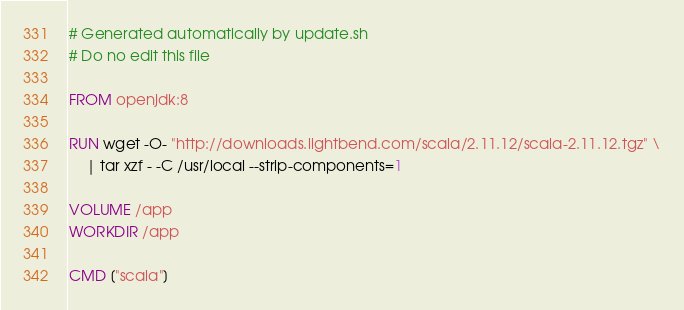Convert code to text. <code><loc_0><loc_0><loc_500><loc_500><_Dockerfile_># Generated automatically by update.sh
# Do no edit this file

FROM openjdk:8

RUN wget -O- "http://downloads.lightbend.com/scala/2.11.12/scala-2.11.12.tgz" \
    | tar xzf - -C /usr/local --strip-components=1

VOLUME /app
WORKDIR /app

CMD ["scala"]
</code> 